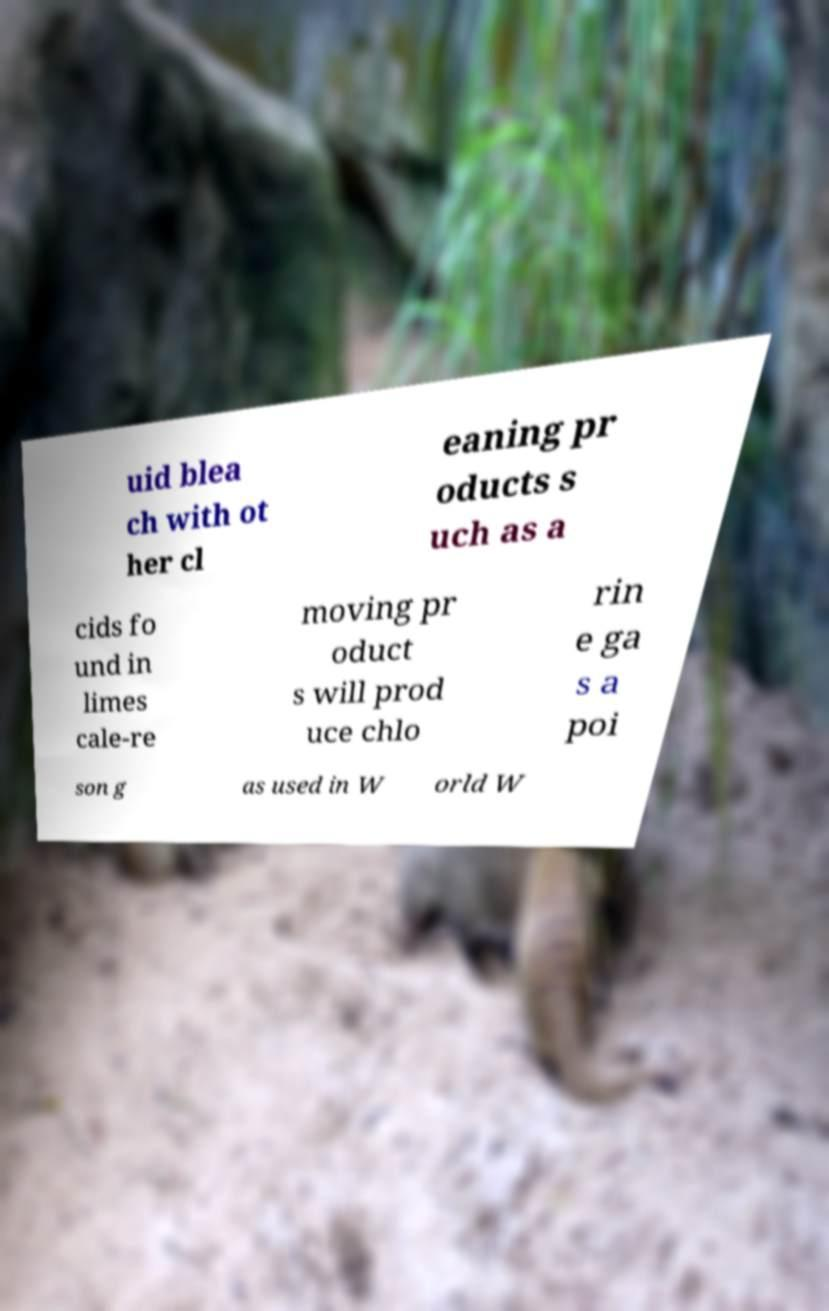What messages or text are displayed in this image? I need them in a readable, typed format. uid blea ch with ot her cl eaning pr oducts s uch as a cids fo und in limes cale-re moving pr oduct s will prod uce chlo rin e ga s a poi son g as used in W orld W 